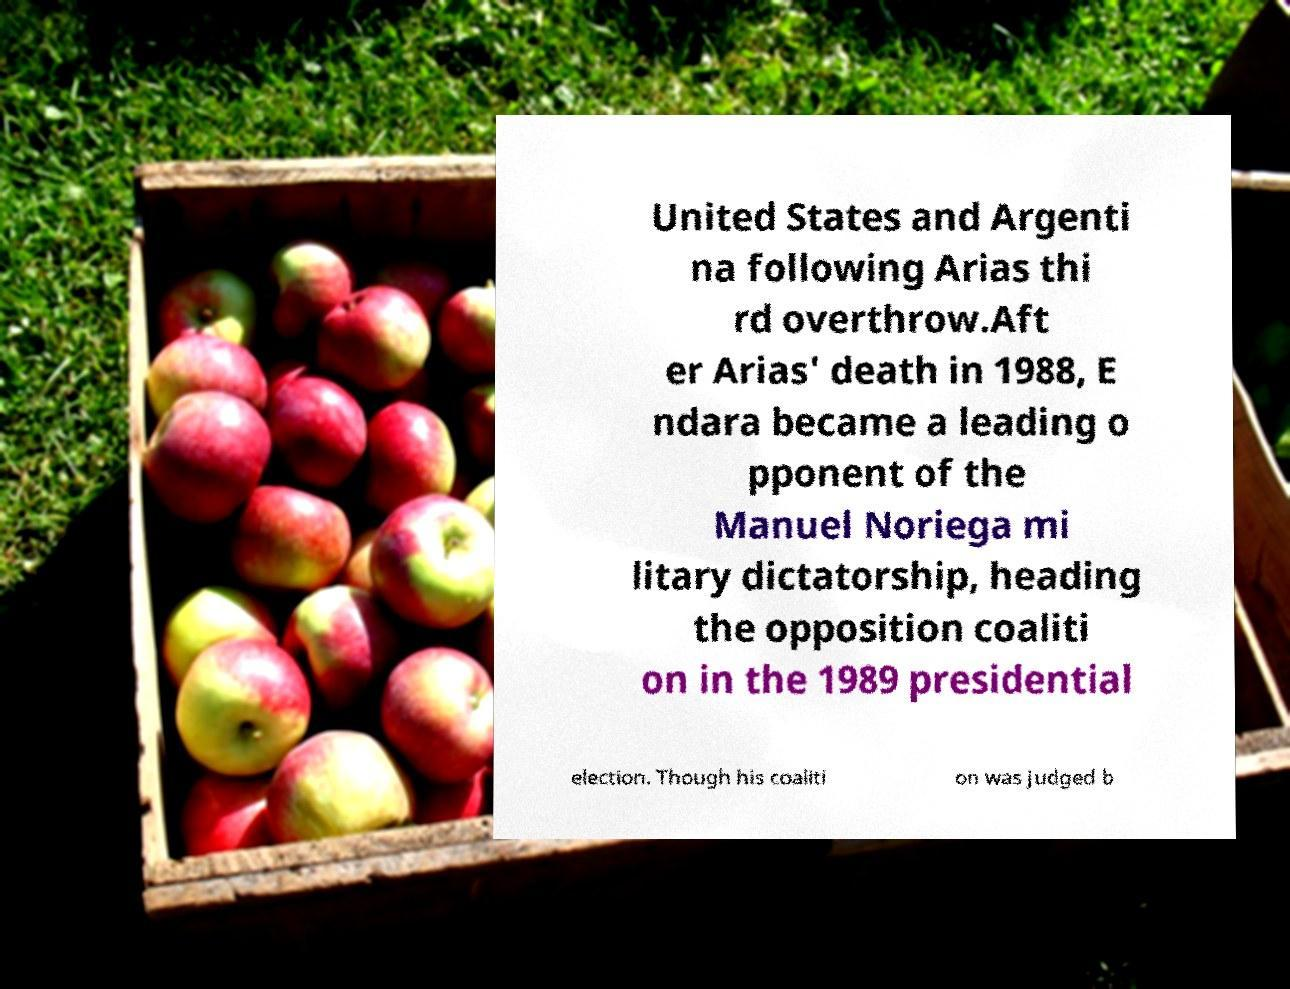There's text embedded in this image that I need extracted. Can you transcribe it verbatim? United States and Argenti na following Arias thi rd overthrow.Aft er Arias' death in 1988, E ndara became a leading o pponent of the Manuel Noriega mi litary dictatorship, heading the opposition coaliti on in the 1989 presidential election. Though his coaliti on was judged b 